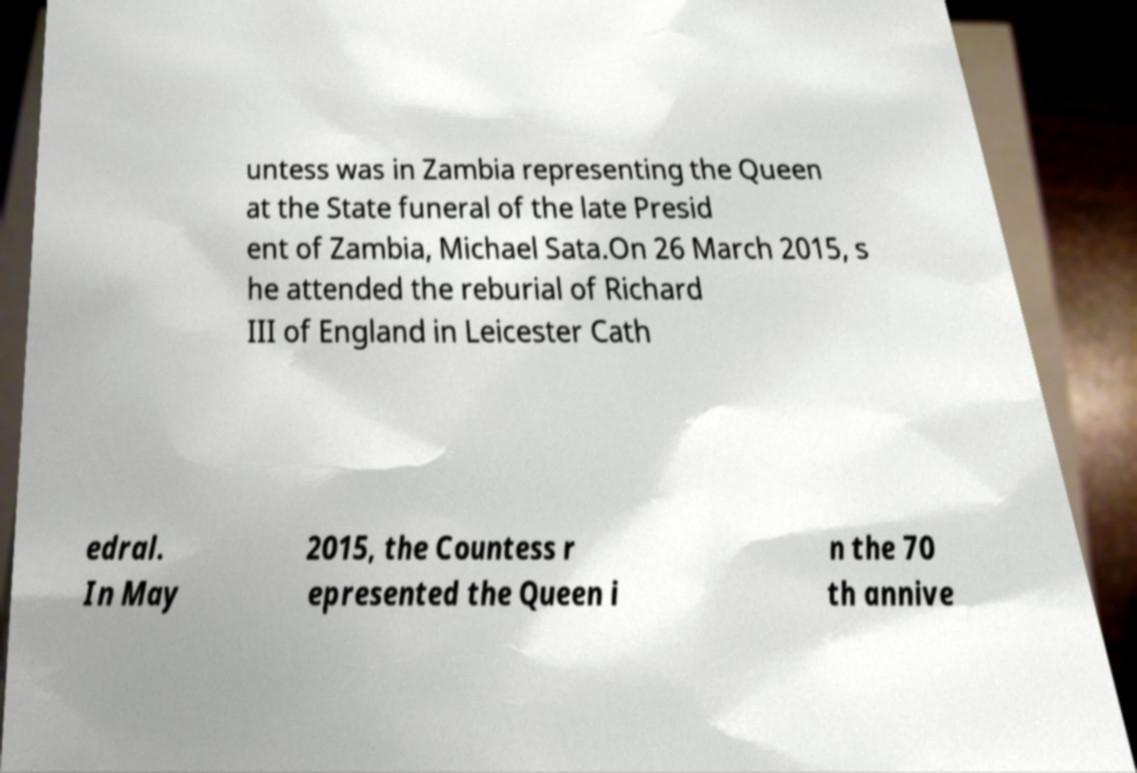Could you extract and type out the text from this image? untess was in Zambia representing the Queen at the State funeral of the late Presid ent of Zambia, Michael Sata.On 26 March 2015, s he attended the reburial of Richard III of England in Leicester Cath edral. In May 2015, the Countess r epresented the Queen i n the 70 th annive 